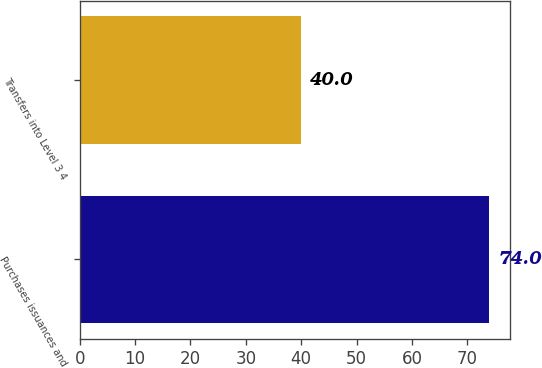<chart> <loc_0><loc_0><loc_500><loc_500><bar_chart><fcel>Purchases issuances and<fcel>Transfers into Level 3 4<nl><fcel>74<fcel>40<nl></chart> 